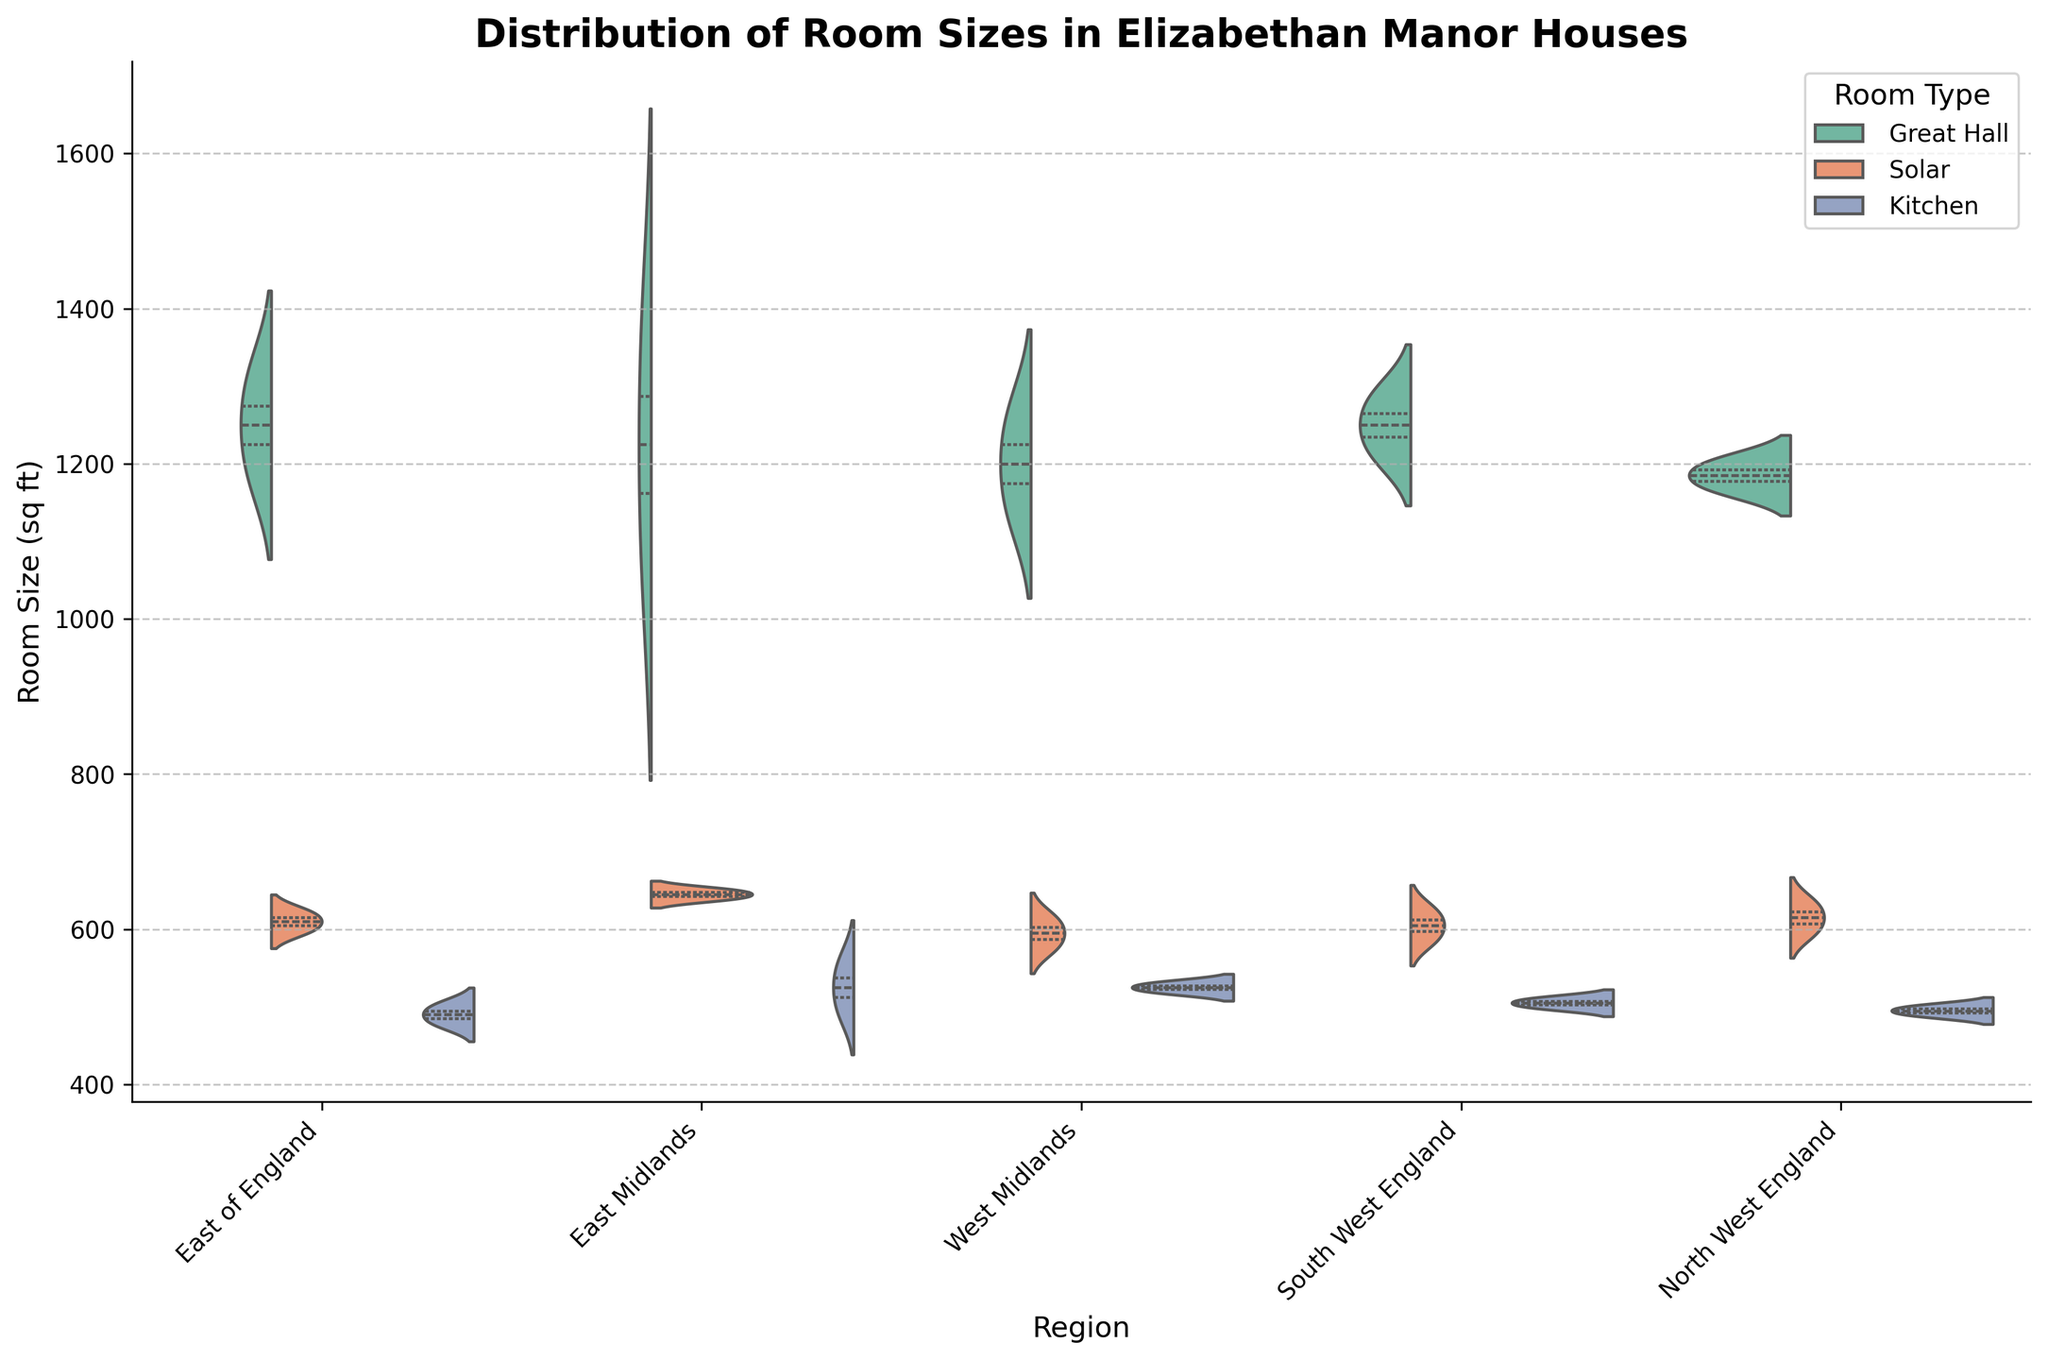What is the title of the figure? The title is located at the top of the figure, presented in bold and larger font size. It describes the overall dataset and comparison.
Answer: Distribution of Room Sizes in Elizabethan Manor Houses What regions are compared in the figure? The regions are displayed on the x-axis, each representing a different geographical area in England.
Answer: East of England, East Midlands, West Midlands, South West England, North West England What room types are included in the chart? The hue legend to the right of the chart categorizes the room types that are being compared in the figure.
Answer: Great Hall, Solar, Kitchen Which region has the widest distribution of room sizes? The width of the violin plot indicates the distribution range of room sizes within each region. Look for the region with the widest spread along the y-axis.
Answer: East Midlands Which room type tends to have the largest sizes across all regions? Compare the median values (indicated by the quartilines within each split violin) for each room type across all regions.
Answer: Great Hall What is the median size of the Great Hall in the West Midlands? The median line inside the "Great Hall" split violin plot for the West Midlands indicates the central tendency.
Answer: Approximately 1200 sq ft Are the room sizes in the North West England region more evenly distributed compared to other regions? Assess the width and uniformity of each violin plot's distribution within the region. More evenly distributed data will show a more consistent width.
Answer: Yes, they appear relatively even Which region shows the most overlapping of room sizes for different room types? Look at the extent of overlap in the width distribution of each room type within a region.
Answer: East of England In which region is the kitchen size consistently the smallest? Identify the region where the Kitchens' violin plots are generally lowest on the y-axis.
Answer: North West England Is there a region where the median size of the Solar is larger than the median size of the Kitchen and smaller than the median size of the Great Hall? Compare the median lines for Solar to both Kitchen and Great Hall within each region to find one where the Solar's median size is in between the other two.
Answer: Yes, in most regions 